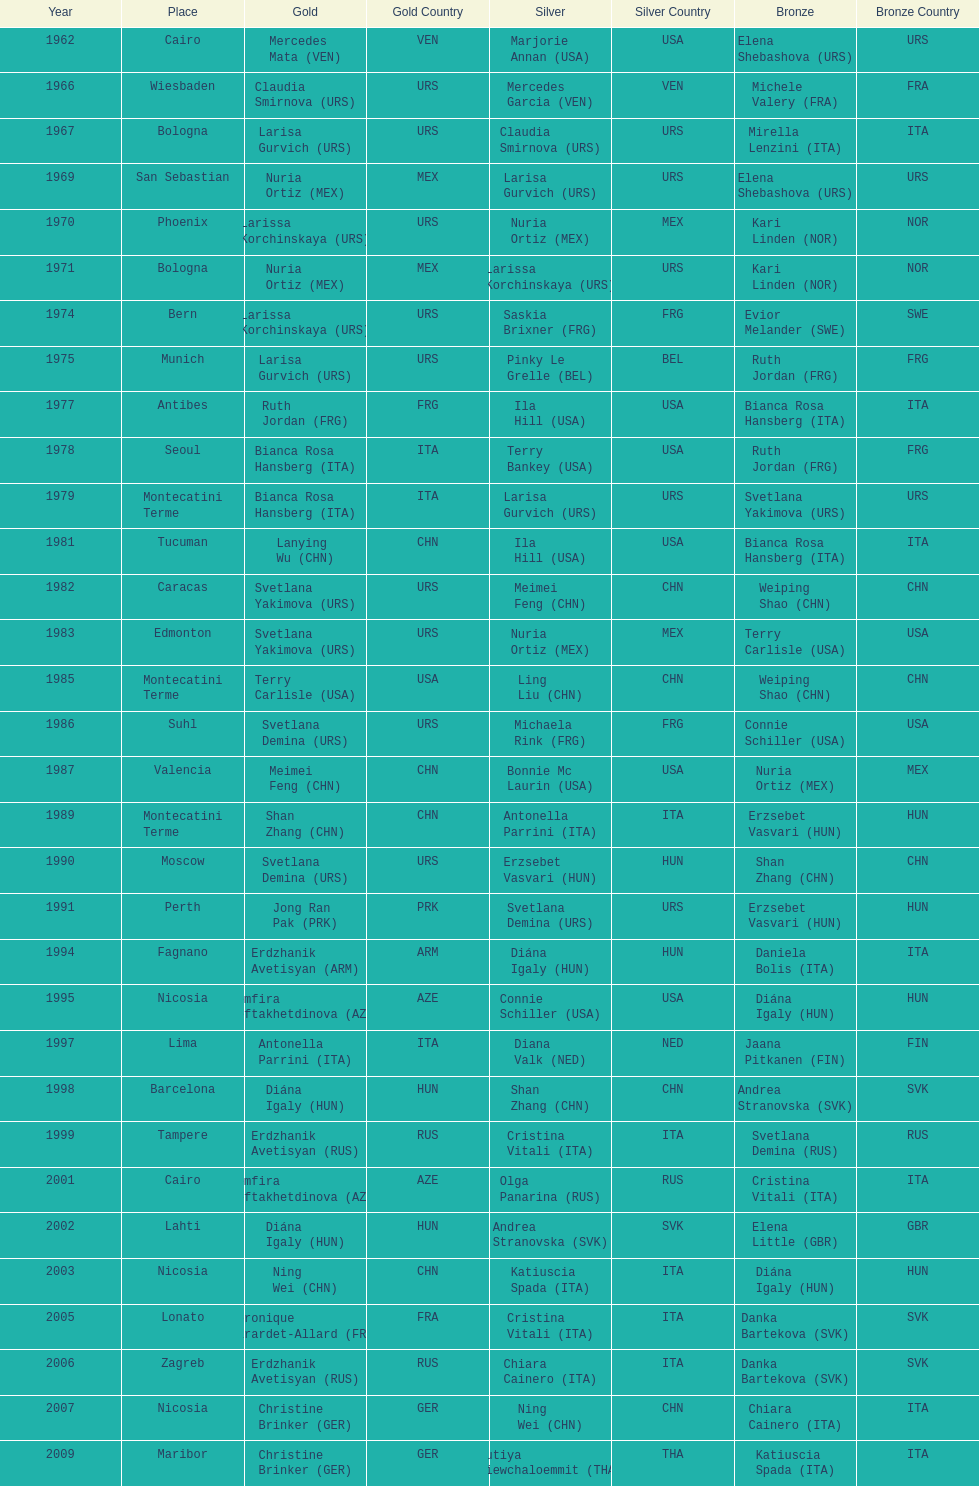Which country has won more gold medals: china or mexico? China. 